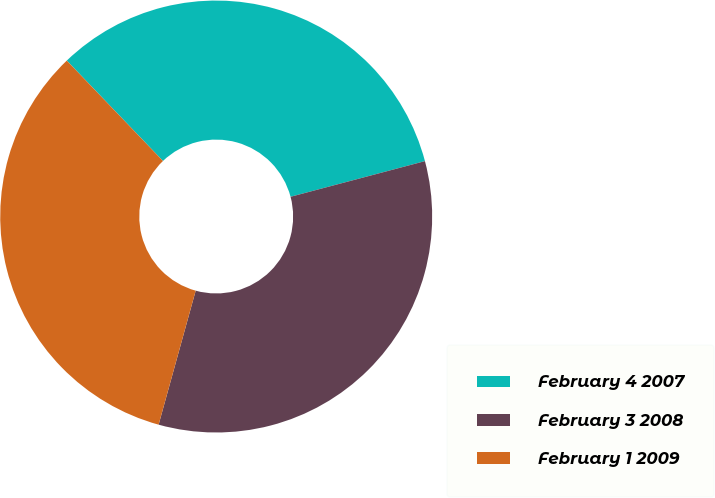Convert chart. <chart><loc_0><loc_0><loc_500><loc_500><pie_chart><fcel>February 4 2007<fcel>February 3 2008<fcel>February 1 2009<nl><fcel>33.03%<fcel>33.42%<fcel>33.54%<nl></chart> 